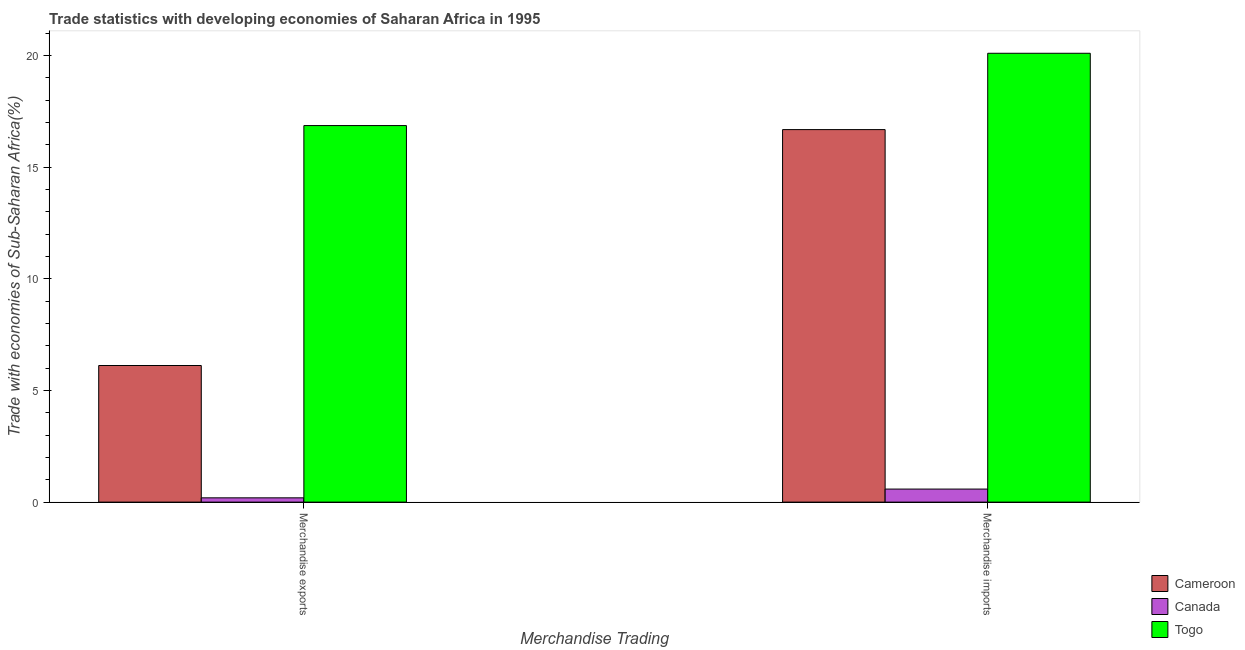How many bars are there on the 2nd tick from the left?
Ensure brevity in your answer.  3. How many bars are there on the 2nd tick from the right?
Offer a very short reply. 3. What is the merchandise imports in Canada?
Make the answer very short. 0.58. Across all countries, what is the maximum merchandise imports?
Offer a terse response. 20.1. Across all countries, what is the minimum merchandise exports?
Offer a very short reply. 0.19. In which country was the merchandise imports maximum?
Your answer should be compact. Togo. In which country was the merchandise imports minimum?
Your answer should be very brief. Canada. What is the total merchandise imports in the graph?
Keep it short and to the point. 37.37. What is the difference between the merchandise imports in Togo and that in Cameroon?
Your response must be concise. 3.42. What is the difference between the merchandise imports in Togo and the merchandise exports in Cameroon?
Your answer should be very brief. 13.98. What is the average merchandise imports per country?
Ensure brevity in your answer.  12.46. What is the difference between the merchandise imports and merchandise exports in Togo?
Offer a very short reply. 3.24. In how many countries, is the merchandise exports greater than 12 %?
Provide a short and direct response. 1. What is the ratio of the merchandise imports in Togo to that in Cameroon?
Provide a short and direct response. 1.2. What does the 1st bar from the left in Merchandise imports represents?
Your answer should be compact. Cameroon. How many bars are there?
Your response must be concise. 6. Are all the bars in the graph horizontal?
Your response must be concise. No. How many countries are there in the graph?
Provide a succinct answer. 3. Are the values on the major ticks of Y-axis written in scientific E-notation?
Your answer should be very brief. No. Does the graph contain grids?
Your response must be concise. No. Where does the legend appear in the graph?
Provide a short and direct response. Bottom right. How are the legend labels stacked?
Make the answer very short. Vertical. What is the title of the graph?
Your answer should be compact. Trade statistics with developing economies of Saharan Africa in 1995. What is the label or title of the X-axis?
Your response must be concise. Merchandise Trading. What is the label or title of the Y-axis?
Ensure brevity in your answer.  Trade with economies of Sub-Saharan Africa(%). What is the Trade with economies of Sub-Saharan Africa(%) in Cameroon in Merchandise exports?
Your answer should be compact. 6.12. What is the Trade with economies of Sub-Saharan Africa(%) in Canada in Merchandise exports?
Ensure brevity in your answer.  0.19. What is the Trade with economies of Sub-Saharan Africa(%) of Togo in Merchandise exports?
Provide a short and direct response. 16.86. What is the Trade with economies of Sub-Saharan Africa(%) in Cameroon in Merchandise imports?
Keep it short and to the point. 16.68. What is the Trade with economies of Sub-Saharan Africa(%) in Canada in Merchandise imports?
Provide a succinct answer. 0.58. What is the Trade with economies of Sub-Saharan Africa(%) in Togo in Merchandise imports?
Make the answer very short. 20.1. Across all Merchandise Trading, what is the maximum Trade with economies of Sub-Saharan Africa(%) in Cameroon?
Your answer should be compact. 16.68. Across all Merchandise Trading, what is the maximum Trade with economies of Sub-Saharan Africa(%) of Canada?
Offer a terse response. 0.58. Across all Merchandise Trading, what is the maximum Trade with economies of Sub-Saharan Africa(%) of Togo?
Offer a very short reply. 20.1. Across all Merchandise Trading, what is the minimum Trade with economies of Sub-Saharan Africa(%) of Cameroon?
Offer a very short reply. 6.12. Across all Merchandise Trading, what is the minimum Trade with economies of Sub-Saharan Africa(%) in Canada?
Provide a short and direct response. 0.19. Across all Merchandise Trading, what is the minimum Trade with economies of Sub-Saharan Africa(%) in Togo?
Your response must be concise. 16.86. What is the total Trade with economies of Sub-Saharan Africa(%) in Cameroon in the graph?
Give a very brief answer. 22.8. What is the total Trade with economies of Sub-Saharan Africa(%) of Canada in the graph?
Your response must be concise. 0.78. What is the total Trade with economies of Sub-Saharan Africa(%) in Togo in the graph?
Provide a succinct answer. 36.96. What is the difference between the Trade with economies of Sub-Saharan Africa(%) in Cameroon in Merchandise exports and that in Merchandise imports?
Your answer should be compact. -10.56. What is the difference between the Trade with economies of Sub-Saharan Africa(%) of Canada in Merchandise exports and that in Merchandise imports?
Your response must be concise. -0.39. What is the difference between the Trade with economies of Sub-Saharan Africa(%) in Togo in Merchandise exports and that in Merchandise imports?
Ensure brevity in your answer.  -3.24. What is the difference between the Trade with economies of Sub-Saharan Africa(%) of Cameroon in Merchandise exports and the Trade with economies of Sub-Saharan Africa(%) of Canada in Merchandise imports?
Provide a short and direct response. 5.53. What is the difference between the Trade with economies of Sub-Saharan Africa(%) in Cameroon in Merchandise exports and the Trade with economies of Sub-Saharan Africa(%) in Togo in Merchandise imports?
Make the answer very short. -13.98. What is the difference between the Trade with economies of Sub-Saharan Africa(%) of Canada in Merchandise exports and the Trade with economies of Sub-Saharan Africa(%) of Togo in Merchandise imports?
Your answer should be very brief. -19.91. What is the average Trade with economies of Sub-Saharan Africa(%) of Cameroon per Merchandise Trading?
Your response must be concise. 11.4. What is the average Trade with economies of Sub-Saharan Africa(%) of Canada per Merchandise Trading?
Provide a succinct answer. 0.39. What is the average Trade with economies of Sub-Saharan Africa(%) in Togo per Merchandise Trading?
Provide a short and direct response. 18.48. What is the difference between the Trade with economies of Sub-Saharan Africa(%) of Cameroon and Trade with economies of Sub-Saharan Africa(%) of Canada in Merchandise exports?
Offer a very short reply. 5.93. What is the difference between the Trade with economies of Sub-Saharan Africa(%) of Cameroon and Trade with economies of Sub-Saharan Africa(%) of Togo in Merchandise exports?
Ensure brevity in your answer.  -10.74. What is the difference between the Trade with economies of Sub-Saharan Africa(%) of Canada and Trade with economies of Sub-Saharan Africa(%) of Togo in Merchandise exports?
Provide a succinct answer. -16.67. What is the difference between the Trade with economies of Sub-Saharan Africa(%) of Cameroon and Trade with economies of Sub-Saharan Africa(%) of Canada in Merchandise imports?
Offer a very short reply. 16.1. What is the difference between the Trade with economies of Sub-Saharan Africa(%) in Cameroon and Trade with economies of Sub-Saharan Africa(%) in Togo in Merchandise imports?
Provide a short and direct response. -3.42. What is the difference between the Trade with economies of Sub-Saharan Africa(%) in Canada and Trade with economies of Sub-Saharan Africa(%) in Togo in Merchandise imports?
Your response must be concise. -19.52. What is the ratio of the Trade with economies of Sub-Saharan Africa(%) of Cameroon in Merchandise exports to that in Merchandise imports?
Ensure brevity in your answer.  0.37. What is the ratio of the Trade with economies of Sub-Saharan Africa(%) of Canada in Merchandise exports to that in Merchandise imports?
Offer a terse response. 0.33. What is the ratio of the Trade with economies of Sub-Saharan Africa(%) in Togo in Merchandise exports to that in Merchandise imports?
Give a very brief answer. 0.84. What is the difference between the highest and the second highest Trade with economies of Sub-Saharan Africa(%) of Cameroon?
Provide a short and direct response. 10.56. What is the difference between the highest and the second highest Trade with economies of Sub-Saharan Africa(%) of Canada?
Keep it short and to the point. 0.39. What is the difference between the highest and the second highest Trade with economies of Sub-Saharan Africa(%) in Togo?
Give a very brief answer. 3.24. What is the difference between the highest and the lowest Trade with economies of Sub-Saharan Africa(%) of Cameroon?
Make the answer very short. 10.56. What is the difference between the highest and the lowest Trade with economies of Sub-Saharan Africa(%) of Canada?
Give a very brief answer. 0.39. What is the difference between the highest and the lowest Trade with economies of Sub-Saharan Africa(%) of Togo?
Provide a short and direct response. 3.24. 